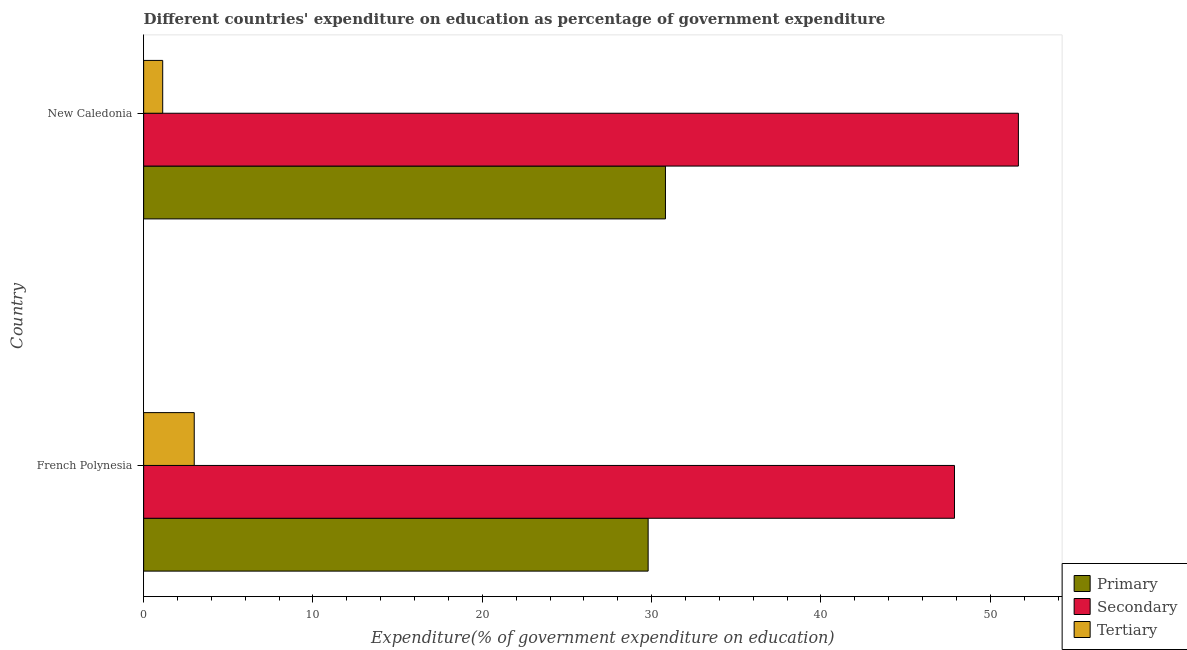How many different coloured bars are there?
Offer a terse response. 3. How many groups of bars are there?
Your answer should be compact. 2. How many bars are there on the 2nd tick from the bottom?
Provide a succinct answer. 3. What is the label of the 2nd group of bars from the top?
Offer a terse response. French Polynesia. In how many cases, is the number of bars for a given country not equal to the number of legend labels?
Your response must be concise. 0. What is the expenditure on primary education in New Caledonia?
Offer a very short reply. 30.82. Across all countries, what is the maximum expenditure on secondary education?
Keep it short and to the point. 51.66. Across all countries, what is the minimum expenditure on tertiary education?
Provide a short and direct response. 1.13. In which country was the expenditure on secondary education maximum?
Offer a terse response. New Caledonia. In which country was the expenditure on tertiary education minimum?
Your answer should be very brief. New Caledonia. What is the total expenditure on primary education in the graph?
Your response must be concise. 60.61. What is the difference between the expenditure on secondary education in French Polynesia and that in New Caledonia?
Your response must be concise. -3.77. What is the difference between the expenditure on primary education in French Polynesia and the expenditure on tertiary education in New Caledonia?
Give a very brief answer. 28.67. What is the average expenditure on primary education per country?
Offer a terse response. 30.3. What is the difference between the expenditure on tertiary education and expenditure on primary education in French Polynesia?
Keep it short and to the point. -26.8. In how many countries, is the expenditure on primary education greater than 18 %?
Offer a terse response. 2. What is the ratio of the expenditure on primary education in French Polynesia to that in New Caledonia?
Provide a succinct answer. 0.97. Is the difference between the expenditure on secondary education in French Polynesia and New Caledonia greater than the difference between the expenditure on tertiary education in French Polynesia and New Caledonia?
Your response must be concise. No. What does the 1st bar from the top in French Polynesia represents?
Provide a short and direct response. Tertiary. What does the 2nd bar from the bottom in New Caledonia represents?
Provide a short and direct response. Secondary. Is it the case that in every country, the sum of the expenditure on primary education and expenditure on secondary education is greater than the expenditure on tertiary education?
Ensure brevity in your answer.  Yes. How many bars are there?
Provide a short and direct response. 6. Are the values on the major ticks of X-axis written in scientific E-notation?
Your response must be concise. No. Does the graph contain any zero values?
Provide a succinct answer. No. Does the graph contain grids?
Your answer should be compact. No. Where does the legend appear in the graph?
Give a very brief answer. Bottom right. How many legend labels are there?
Ensure brevity in your answer.  3. What is the title of the graph?
Offer a very short reply. Different countries' expenditure on education as percentage of government expenditure. Does "Ages 15-64" appear as one of the legend labels in the graph?
Keep it short and to the point. No. What is the label or title of the X-axis?
Offer a very short reply. Expenditure(% of government expenditure on education). What is the Expenditure(% of government expenditure on education) in Primary in French Polynesia?
Your answer should be very brief. 29.79. What is the Expenditure(% of government expenditure on education) of Secondary in French Polynesia?
Your response must be concise. 47.88. What is the Expenditure(% of government expenditure on education) in Tertiary in French Polynesia?
Your response must be concise. 2.99. What is the Expenditure(% of government expenditure on education) in Primary in New Caledonia?
Provide a short and direct response. 30.82. What is the Expenditure(% of government expenditure on education) of Secondary in New Caledonia?
Your answer should be very brief. 51.66. What is the Expenditure(% of government expenditure on education) in Tertiary in New Caledonia?
Offer a terse response. 1.13. Across all countries, what is the maximum Expenditure(% of government expenditure on education) in Primary?
Your response must be concise. 30.82. Across all countries, what is the maximum Expenditure(% of government expenditure on education) in Secondary?
Your answer should be very brief. 51.66. Across all countries, what is the maximum Expenditure(% of government expenditure on education) of Tertiary?
Give a very brief answer. 2.99. Across all countries, what is the minimum Expenditure(% of government expenditure on education) in Primary?
Make the answer very short. 29.79. Across all countries, what is the minimum Expenditure(% of government expenditure on education) of Secondary?
Keep it short and to the point. 47.88. Across all countries, what is the minimum Expenditure(% of government expenditure on education) of Tertiary?
Offer a very short reply. 1.13. What is the total Expenditure(% of government expenditure on education) in Primary in the graph?
Offer a terse response. 60.61. What is the total Expenditure(% of government expenditure on education) of Secondary in the graph?
Make the answer very short. 99.54. What is the total Expenditure(% of government expenditure on education) in Tertiary in the graph?
Make the answer very short. 4.11. What is the difference between the Expenditure(% of government expenditure on education) in Primary in French Polynesia and that in New Caledonia?
Provide a short and direct response. -1.02. What is the difference between the Expenditure(% of government expenditure on education) in Secondary in French Polynesia and that in New Caledonia?
Offer a terse response. -3.77. What is the difference between the Expenditure(% of government expenditure on education) in Tertiary in French Polynesia and that in New Caledonia?
Offer a terse response. 1.86. What is the difference between the Expenditure(% of government expenditure on education) of Primary in French Polynesia and the Expenditure(% of government expenditure on education) of Secondary in New Caledonia?
Provide a short and direct response. -21.87. What is the difference between the Expenditure(% of government expenditure on education) of Primary in French Polynesia and the Expenditure(% of government expenditure on education) of Tertiary in New Caledonia?
Make the answer very short. 28.67. What is the difference between the Expenditure(% of government expenditure on education) of Secondary in French Polynesia and the Expenditure(% of government expenditure on education) of Tertiary in New Caledonia?
Make the answer very short. 46.76. What is the average Expenditure(% of government expenditure on education) of Primary per country?
Your response must be concise. 30.3. What is the average Expenditure(% of government expenditure on education) of Secondary per country?
Ensure brevity in your answer.  49.77. What is the average Expenditure(% of government expenditure on education) of Tertiary per country?
Provide a short and direct response. 2.06. What is the difference between the Expenditure(% of government expenditure on education) in Primary and Expenditure(% of government expenditure on education) in Secondary in French Polynesia?
Provide a succinct answer. -18.09. What is the difference between the Expenditure(% of government expenditure on education) of Primary and Expenditure(% of government expenditure on education) of Tertiary in French Polynesia?
Your answer should be very brief. 26.8. What is the difference between the Expenditure(% of government expenditure on education) of Secondary and Expenditure(% of government expenditure on education) of Tertiary in French Polynesia?
Keep it short and to the point. 44.9. What is the difference between the Expenditure(% of government expenditure on education) in Primary and Expenditure(% of government expenditure on education) in Secondary in New Caledonia?
Your answer should be very brief. -20.84. What is the difference between the Expenditure(% of government expenditure on education) in Primary and Expenditure(% of government expenditure on education) in Tertiary in New Caledonia?
Offer a very short reply. 29.69. What is the difference between the Expenditure(% of government expenditure on education) in Secondary and Expenditure(% of government expenditure on education) in Tertiary in New Caledonia?
Provide a succinct answer. 50.53. What is the ratio of the Expenditure(% of government expenditure on education) in Primary in French Polynesia to that in New Caledonia?
Keep it short and to the point. 0.97. What is the ratio of the Expenditure(% of government expenditure on education) in Secondary in French Polynesia to that in New Caledonia?
Provide a short and direct response. 0.93. What is the ratio of the Expenditure(% of government expenditure on education) of Tertiary in French Polynesia to that in New Caledonia?
Your response must be concise. 2.65. What is the difference between the highest and the second highest Expenditure(% of government expenditure on education) in Primary?
Offer a terse response. 1.02. What is the difference between the highest and the second highest Expenditure(% of government expenditure on education) in Secondary?
Your answer should be compact. 3.77. What is the difference between the highest and the second highest Expenditure(% of government expenditure on education) in Tertiary?
Make the answer very short. 1.86. What is the difference between the highest and the lowest Expenditure(% of government expenditure on education) in Primary?
Give a very brief answer. 1.02. What is the difference between the highest and the lowest Expenditure(% of government expenditure on education) of Secondary?
Your answer should be very brief. 3.77. What is the difference between the highest and the lowest Expenditure(% of government expenditure on education) in Tertiary?
Provide a short and direct response. 1.86. 